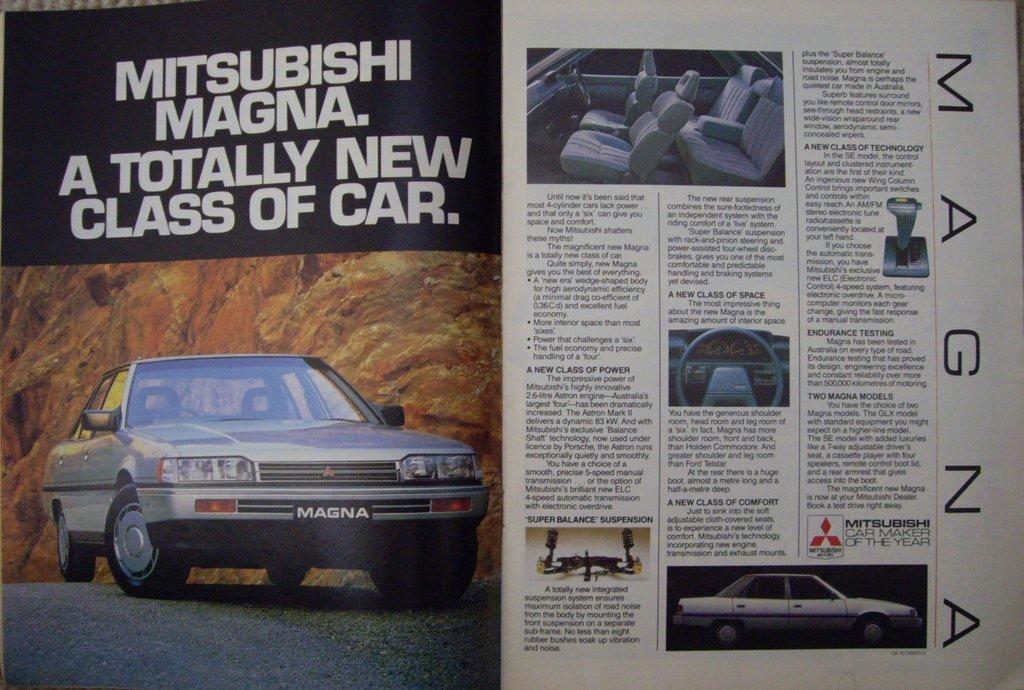Please provide a concise description of this image. In this image there is a poster having a picture of a car. Left bottom there is a car on the poster. Top of it there is some text. Top of image there is an image of a vehicle having seats inside it. Right bottom there is a car image. Middle of image there is a steering picture. Beside it there is some text. 